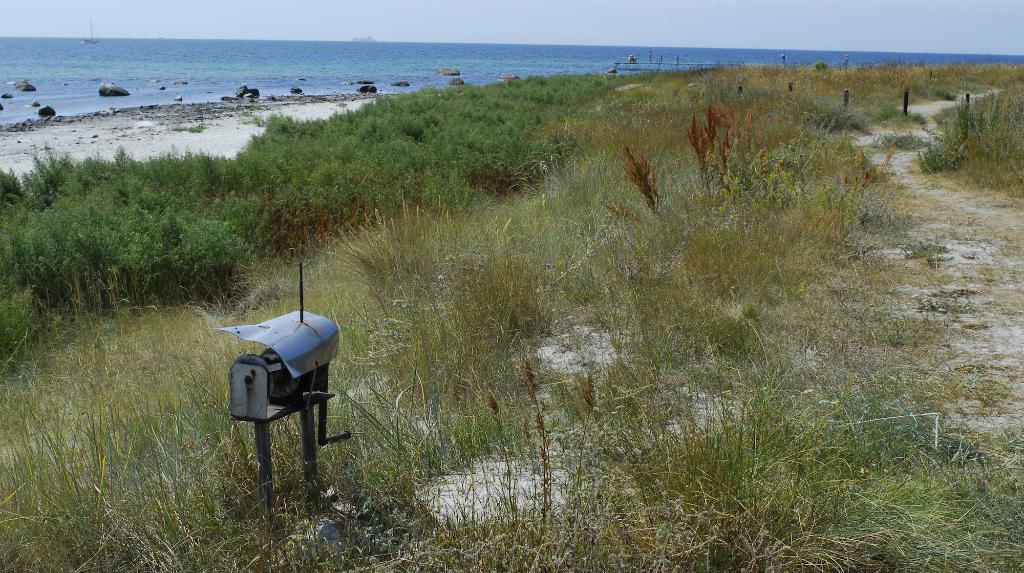What type of ground is visible in the image? There is green grass ground in the image. What is placed in the middle of the ground? There is a machinery motor placed in the middle of the ground. What type of water can be seen in the image? There is blue sea water visible in the image. What type of bucket can be seen on the floor during the competition in the image? There is no bucket or competition present in the image. The image features green grass ground, a machinery motor, and blue sea water. 